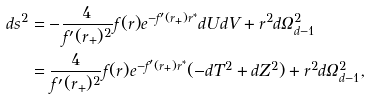<formula> <loc_0><loc_0><loc_500><loc_500>d s ^ { 2 } & = - \frac { 4 } { f ^ { \prime } ( r _ { + } ) ^ { 2 } } f ( r ) e ^ { - f ^ { \prime } ( r _ { + } ) r ^ { * } } d U d V + r ^ { 2 } d \Omega _ { d - 1 } ^ { 2 } \\ & = \frac { 4 } { f ^ { \prime } ( r _ { + } ) ^ { 2 } } f ( r ) e ^ { - f ^ { \prime } ( r _ { + } ) r ^ { * } } ( - d T ^ { 2 } + d Z ^ { 2 } ) + r ^ { 2 } d \Omega _ { d - 1 } ^ { 2 } ,</formula> 